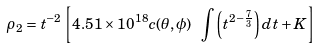Convert formula to latex. <formula><loc_0><loc_0><loc_500><loc_500>\rho _ { 2 } = t ^ { - 2 } \left [ 4 . 5 1 \times 1 0 ^ { 1 8 } c ( \theta , \phi ) \ \int \left ( t ^ { 2 - \frac { 7 } { 3 } } \right ) d t + K \right ]</formula> 